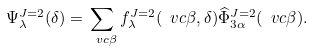<formula> <loc_0><loc_0><loc_500><loc_500>\Psi ^ { J = 2 } _ { \lambda } ( \delta ) = \sum _ { \ v c { \beta } } f ^ { J = 2 } _ { \lambda } ( \ v c { \beta } , \delta ) { \widehat { \Phi } } ^ { J = 2 } _ { 3 \alpha } ( \ v c { \beta } ) .</formula> 